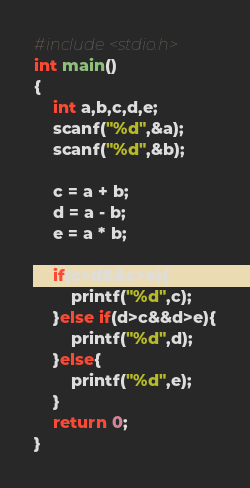<code> <loc_0><loc_0><loc_500><loc_500><_C_>#include<stdio.h>
int main()
{
	int a,b,c,d,e;
	scanf("%d",&a);
	scanf("%d",&b);
	
	c = a + b;
	d = a - b;
	e = a * b;
	
	if(c>d&&c>e){
		printf("%d",c);
	}else if(d>c&&d>e){
		printf("%d",d);
	}else{
		printf("%d",e);
	}
	return 0;
}</code> 